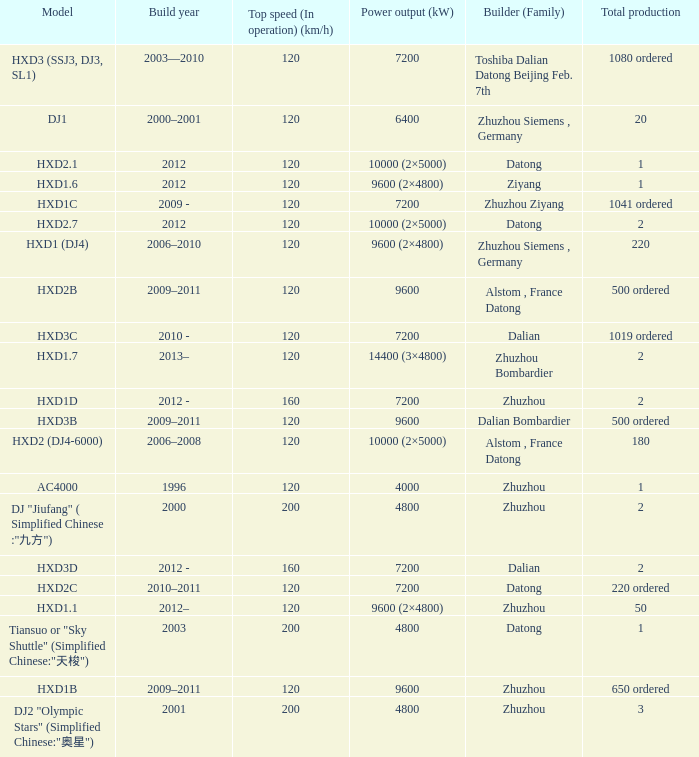What is the power output (kw) of model hxd2b? 9600.0. 